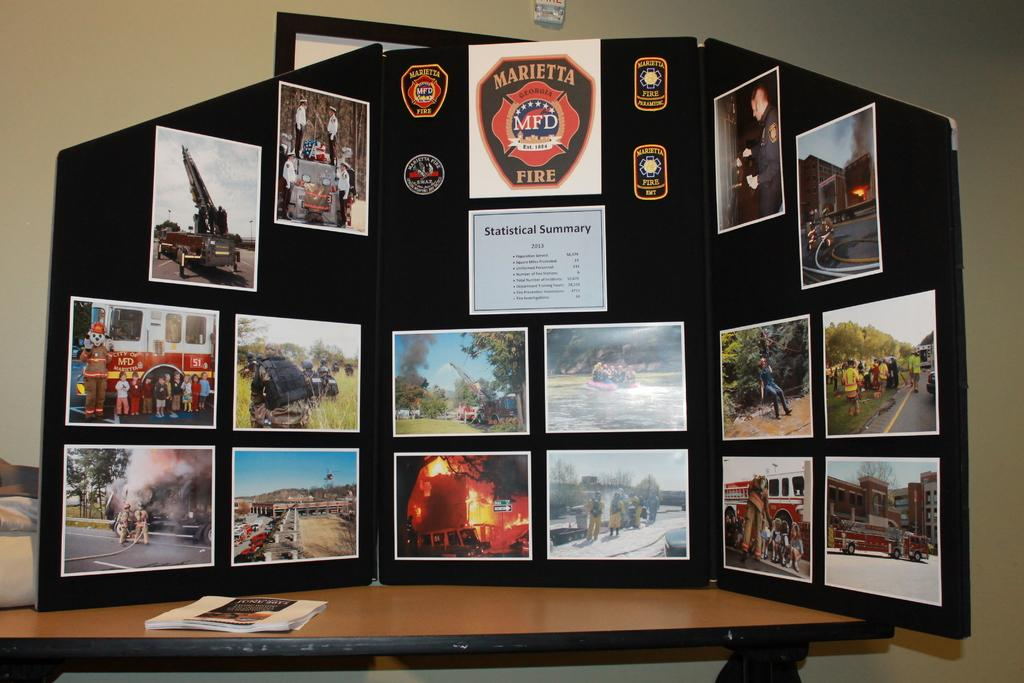What type of structure is visible in the image? There is a wall in the image. What can be seen hanging on the wall? There are photo frames in the image. What piece of furniture is present in the image? There is a table in the image. What item is placed on the table? There is a book on the table. How many cattle are grazing in the image? There are no cattle present in the image. What rule is being enforced in the image? There is no rule being enforced in the image. 